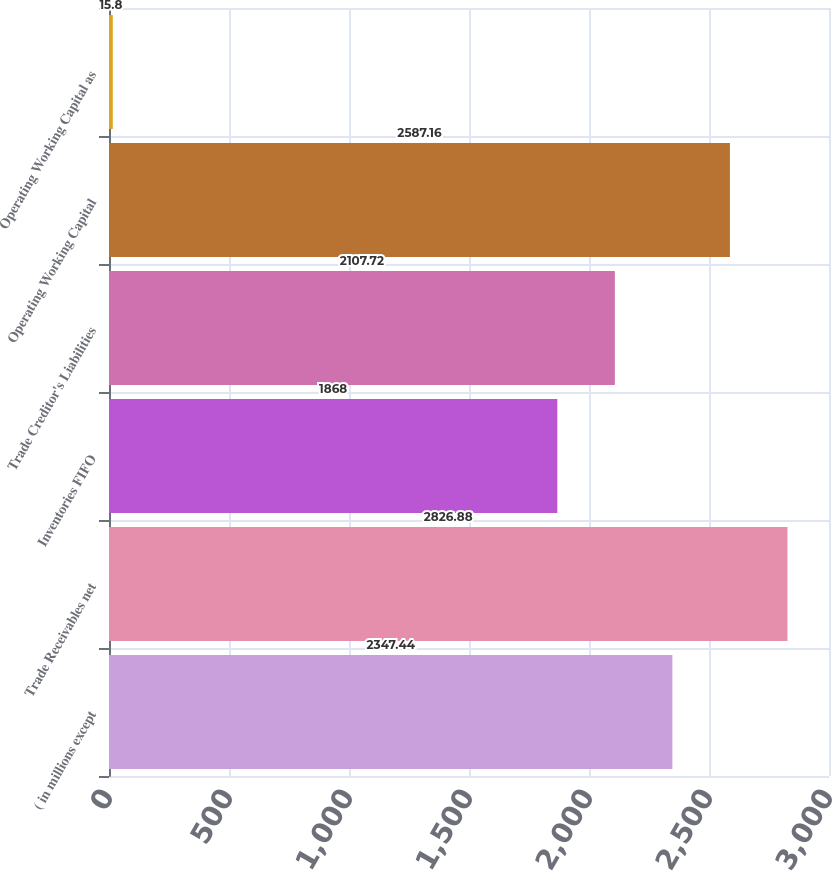<chart> <loc_0><loc_0><loc_500><loc_500><bar_chart><fcel>( in millions except<fcel>Trade Receivables net<fcel>Inventories FIFO<fcel>Trade Creditor's Liabilities<fcel>Operating Working Capital<fcel>Operating Working Capital as<nl><fcel>2347.44<fcel>2826.88<fcel>1868<fcel>2107.72<fcel>2587.16<fcel>15.8<nl></chart> 